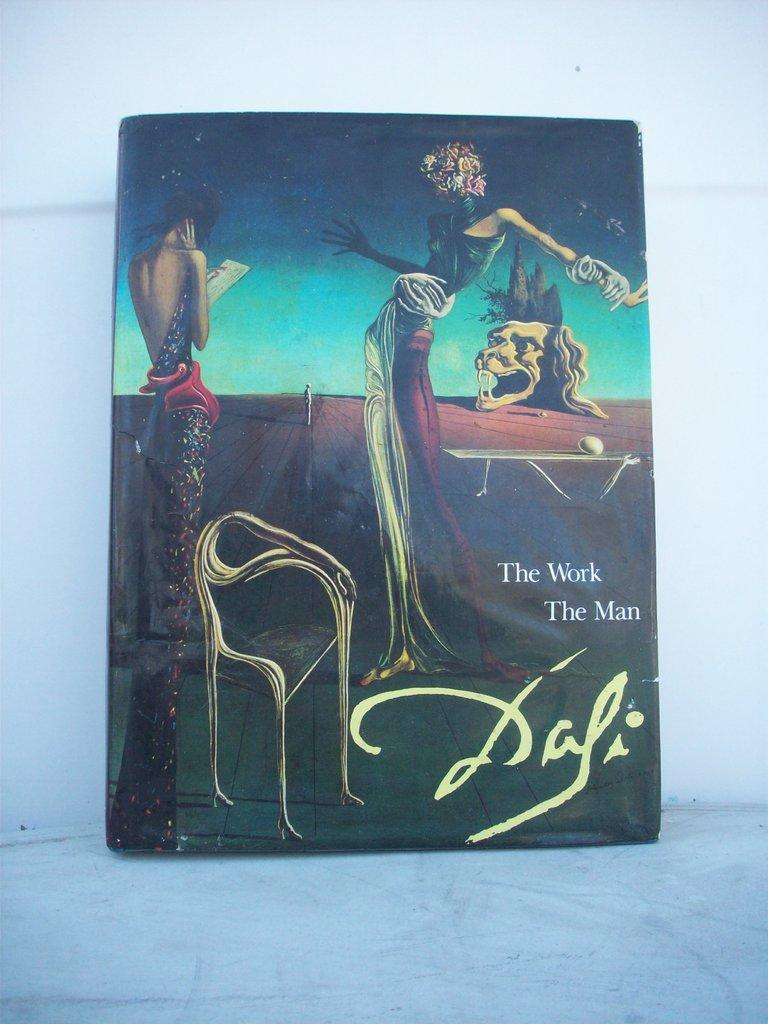What type of book is shown in the image? There is a cartoon book in the image. What is the title of the cartoon book? The title of the book is "The Work The Men". What can be found inside the cartoon book? There are cartoon pictures in the book. What color is the scarf that the pan is wearing in the image? There is no scarf or pan present in the image; it features a cartoon book with the title "The Work The Men". 